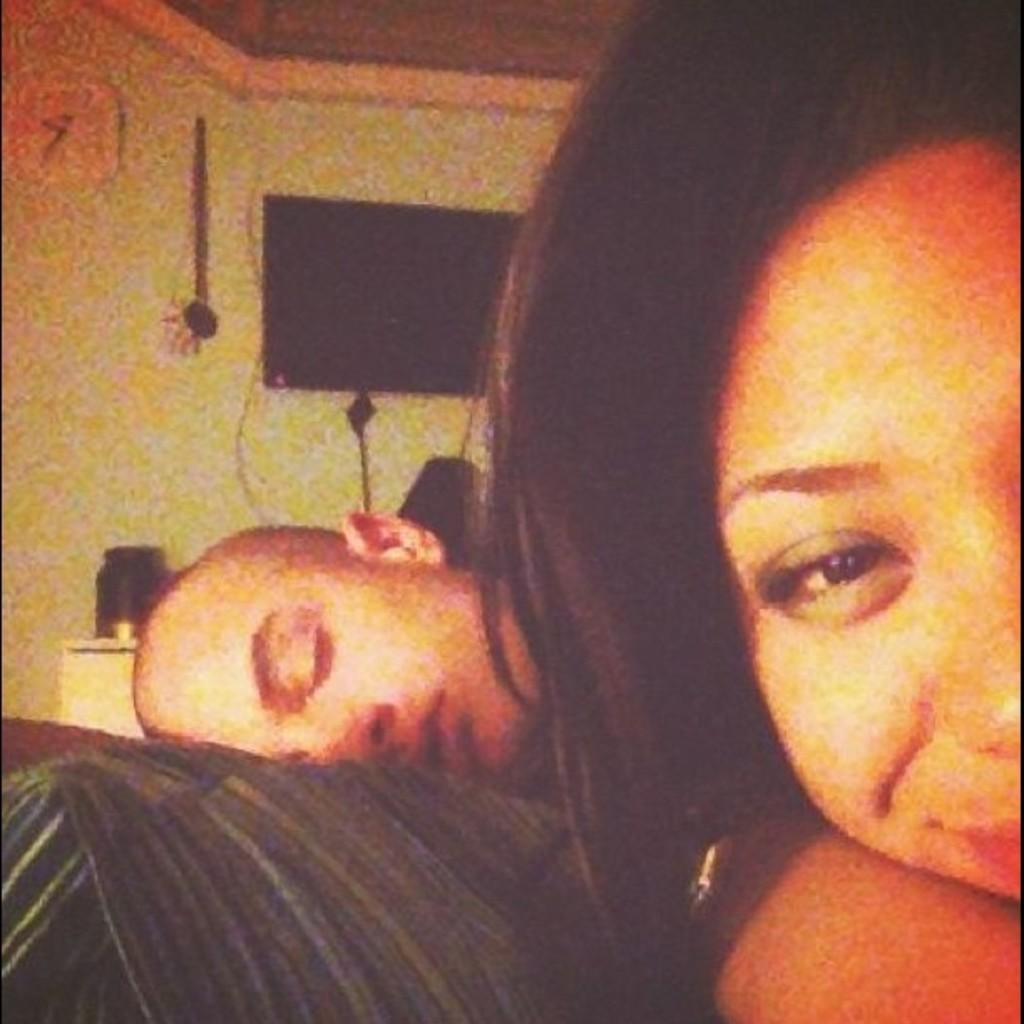How many people are present in the image? There are two people in the image. What can be seen on the wall in the background of the image? There is a television on the wall in the background of the image. Can you describe the background of the image? There are many objects visible in the background of the image. What type of brass instrument is being played by the people in the image? There is no brass instrument present in the image; it only features two people and a television on the wall. 